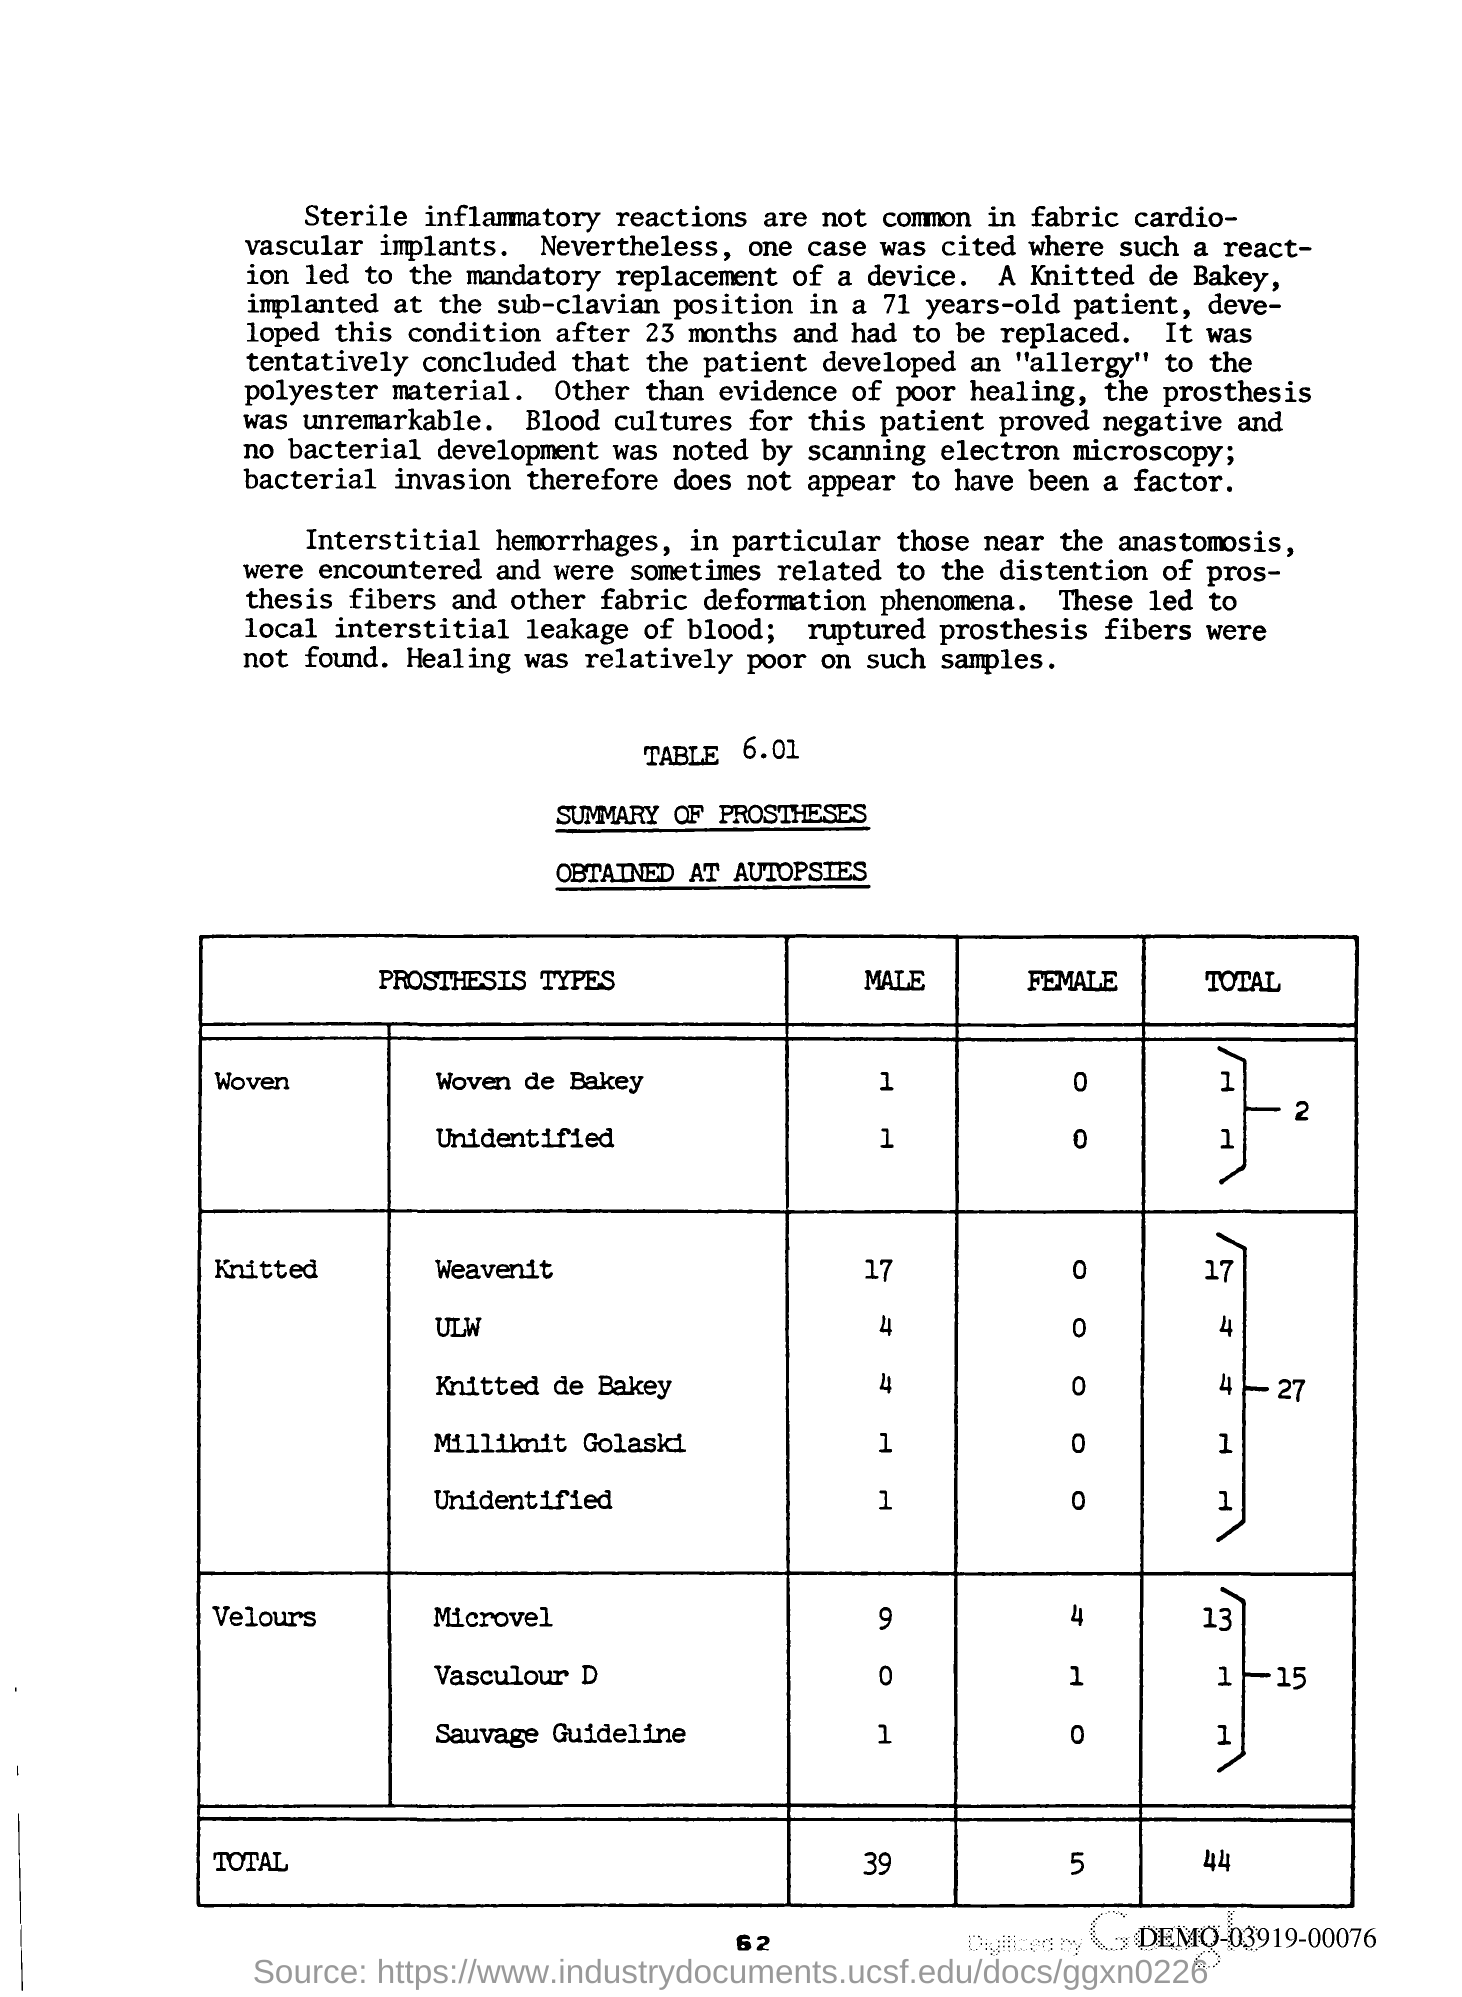What is the Page Number?
Ensure brevity in your answer.  62. 